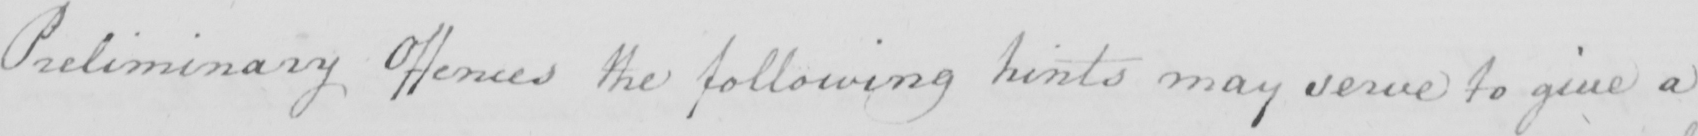Please transcribe the handwritten text in this image. Preliminary Offences the following hints may serve to give a 